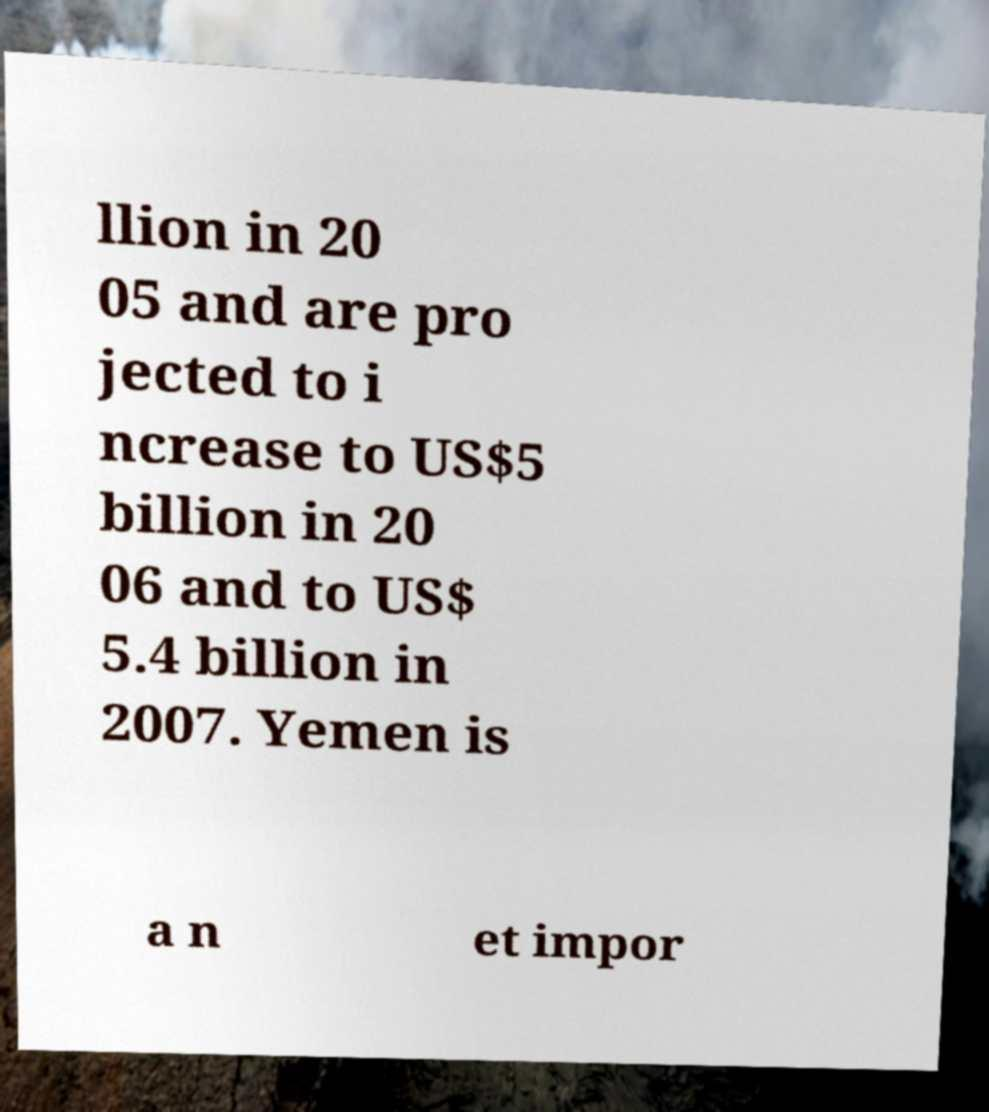Can you accurately transcribe the text from the provided image for me? llion in 20 05 and are pro jected to i ncrease to US$5 billion in 20 06 and to US$ 5.4 billion in 2007. Yemen is a n et impor 